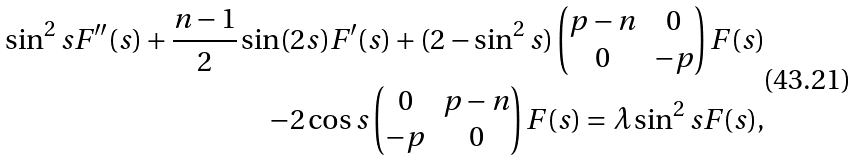Convert formula to latex. <formula><loc_0><loc_0><loc_500><loc_500>\sin ^ { 2 } s F ^ { \prime \prime } ( s ) + \frac { n - 1 } { 2 } \sin ( 2 s ) F ^ { \prime } ( s ) + ( 2 - \sin ^ { 2 } s ) \left ( \begin{matrix} p - n & 0 \\ 0 & - p \end{matrix} \right ) F ( s ) \\ - 2 \cos s \left ( \begin{matrix} 0 & p - n \\ - p & 0 \end{matrix} \right ) F ( s ) = \lambda \sin ^ { 2 } s F ( s ) ,</formula> 